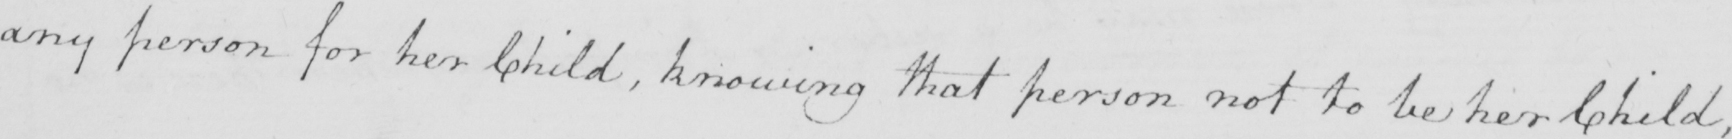Please provide the text content of this handwritten line. any person for her Child , knowing that person not to be her Child , 